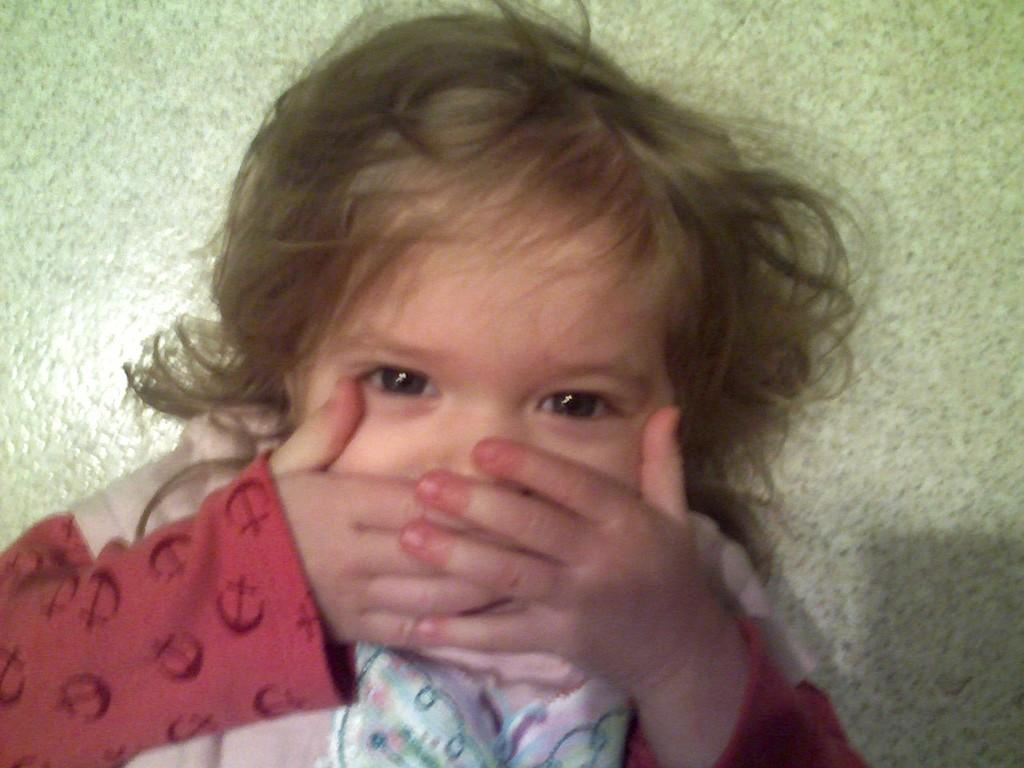What is the main subject of the image? The main subject of the image is a baby. What is the baby doing in the image? The baby is covering her mouth with her hands. What is the baby wearing in the image? The baby is wearing a pink t-shirt. What type of fruit is mentioned in the text of the image? There is no text or fruit mentioned in the image; it only shows a baby covering her mouth with her hands while wearing a pink t-shirt. 